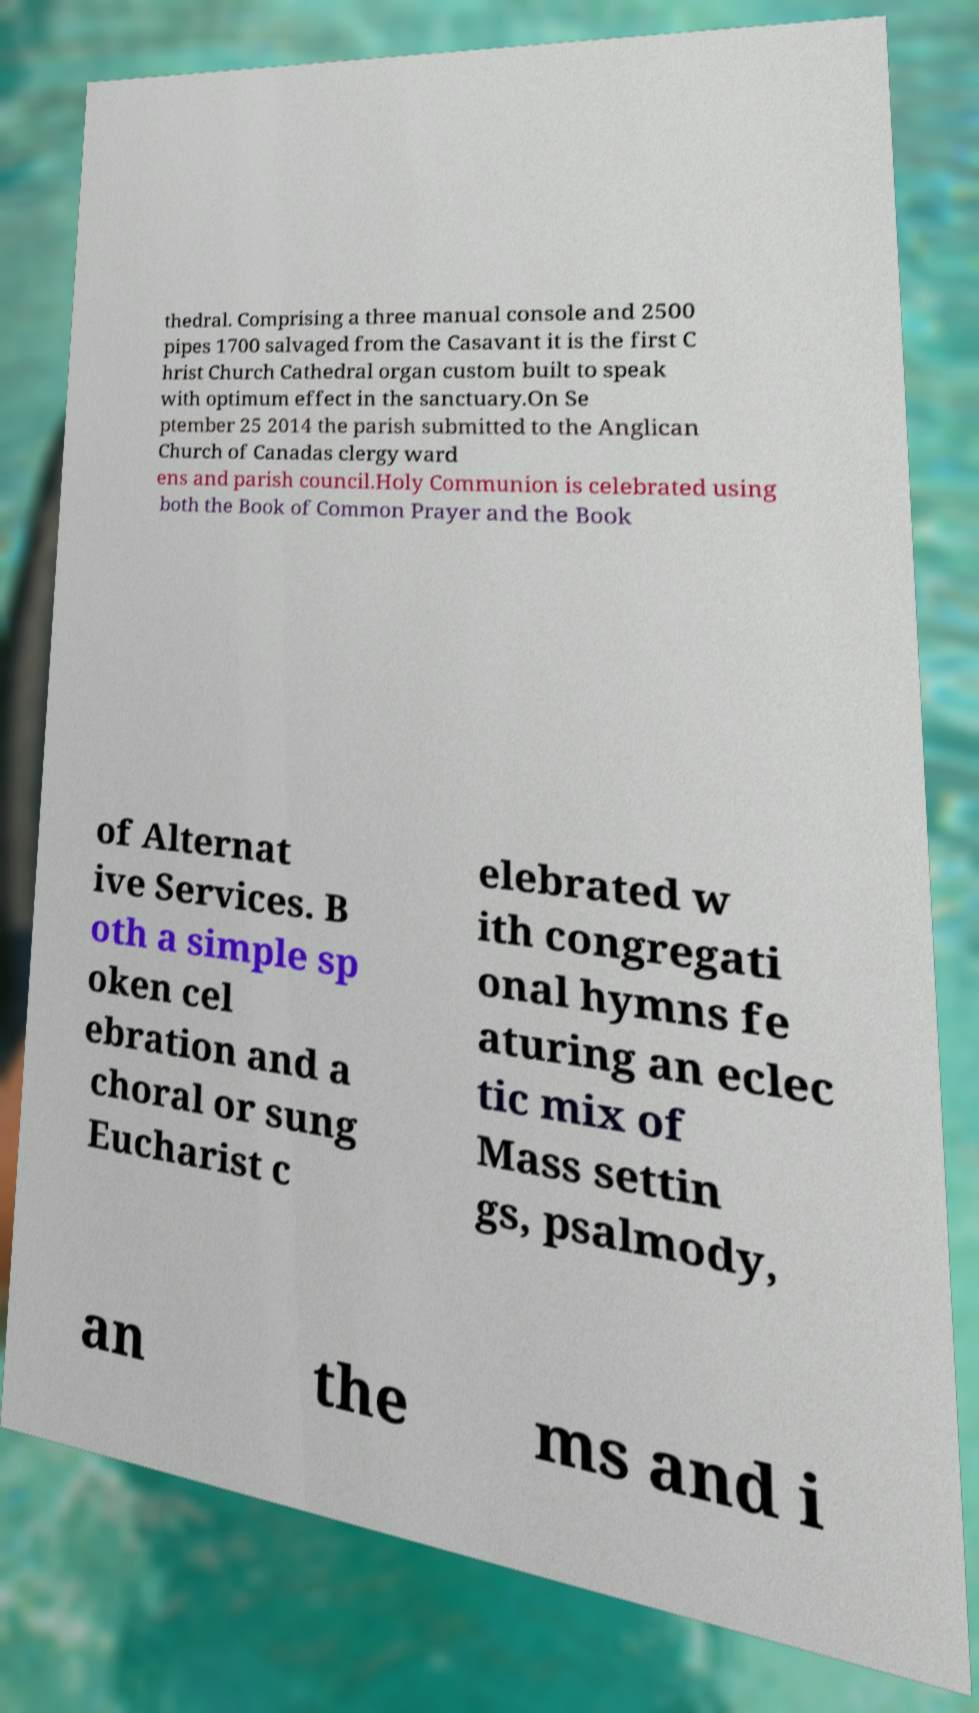What messages or text are displayed in this image? I need them in a readable, typed format. thedral. Comprising a three manual console and 2500 pipes 1700 salvaged from the Casavant it is the first C hrist Church Cathedral organ custom built to speak with optimum effect in the sanctuary.On Se ptember 25 2014 the parish submitted to the Anglican Church of Canadas clergy ward ens and parish council.Holy Communion is celebrated using both the Book of Common Prayer and the Book of Alternat ive Services. B oth a simple sp oken cel ebration and a choral or sung Eucharist c elebrated w ith congregati onal hymns fe aturing an eclec tic mix of Mass settin gs, psalmody, an the ms and i 